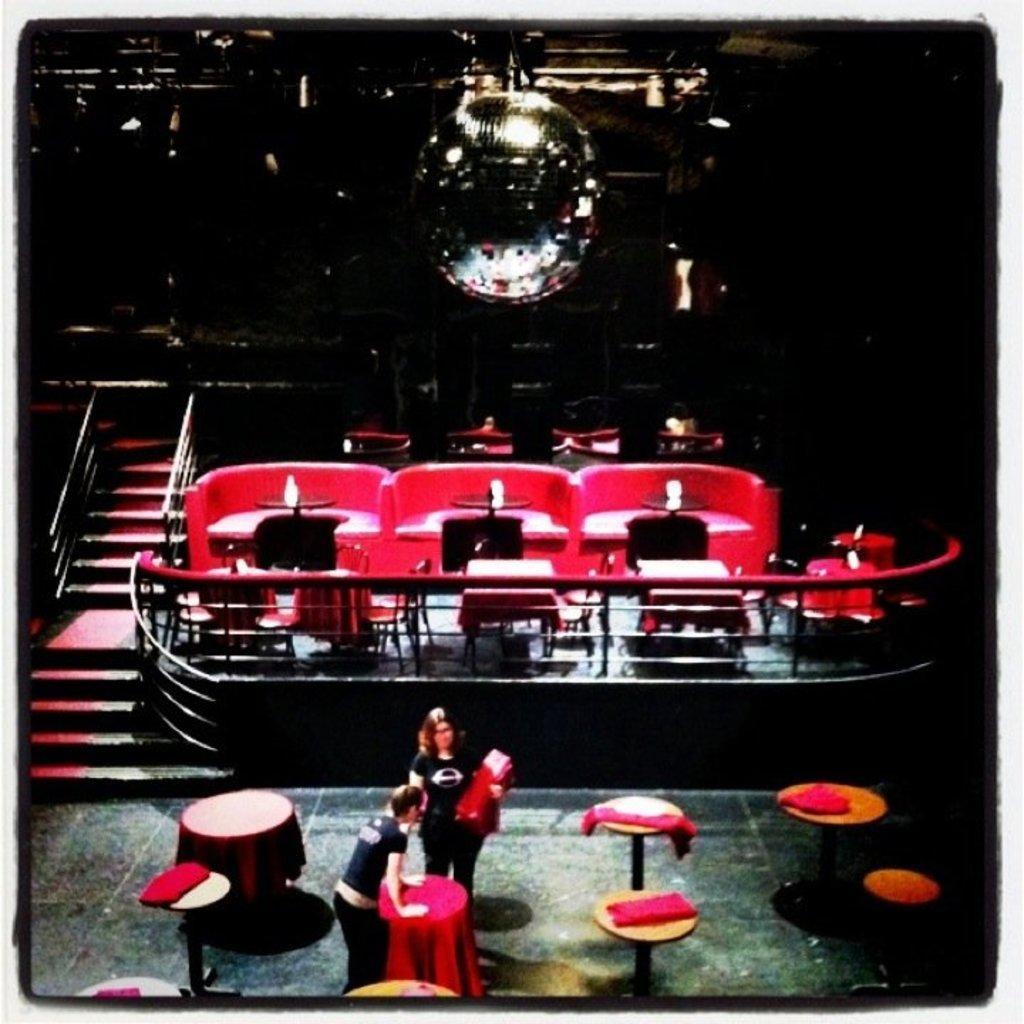How would you summarize this image in a sentence or two? In this image I can see number of tables, stairs, railings and here I can see few people are standing. I can also see this image is little bit in dark. 